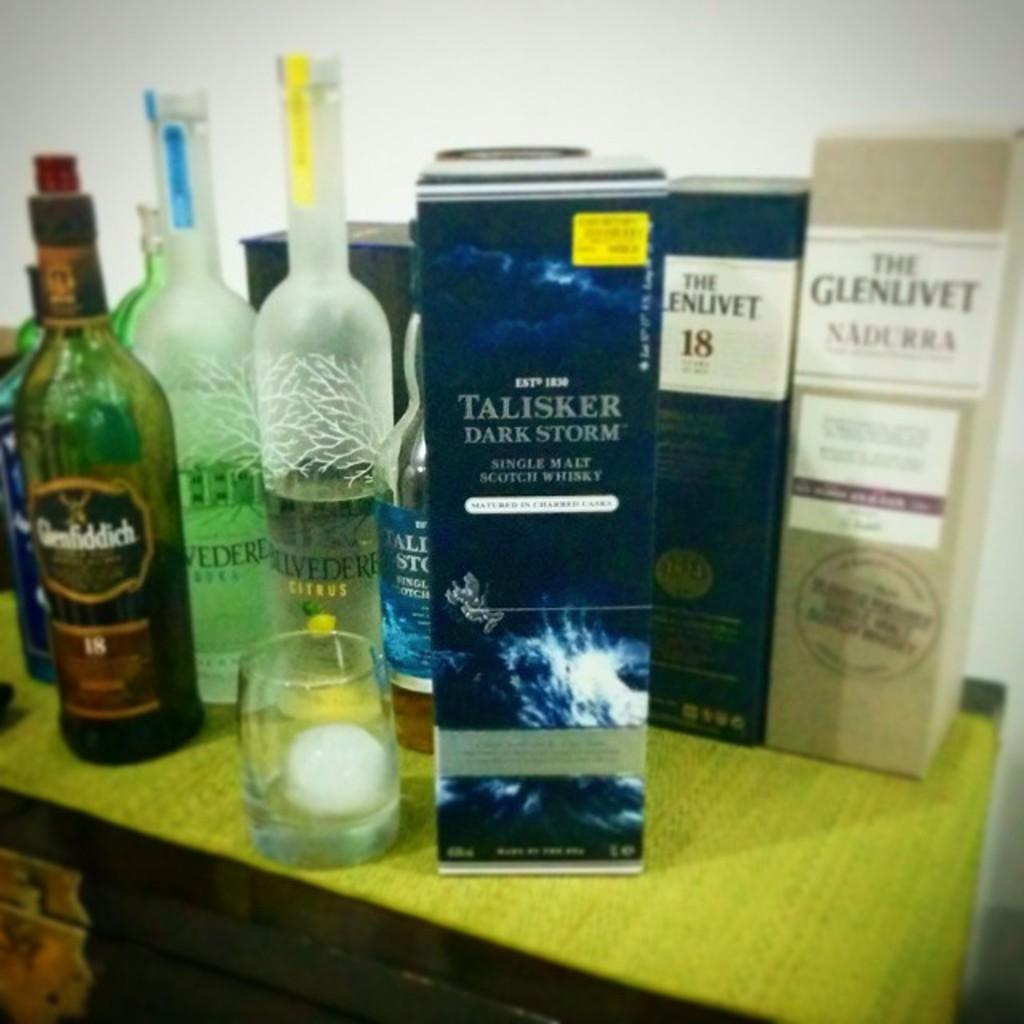<image>
Share a concise interpretation of the image provided. the name Talisker that is on a bottle of something 